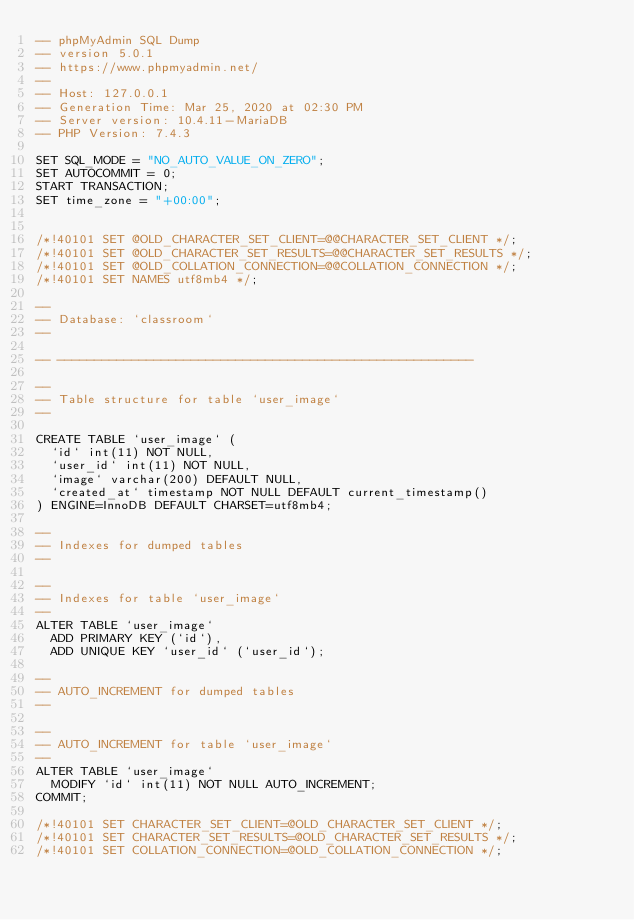Convert code to text. <code><loc_0><loc_0><loc_500><loc_500><_SQL_>-- phpMyAdmin SQL Dump
-- version 5.0.1
-- https://www.phpmyadmin.net/
--
-- Host: 127.0.0.1
-- Generation Time: Mar 25, 2020 at 02:30 PM
-- Server version: 10.4.11-MariaDB
-- PHP Version: 7.4.3

SET SQL_MODE = "NO_AUTO_VALUE_ON_ZERO";
SET AUTOCOMMIT = 0;
START TRANSACTION;
SET time_zone = "+00:00";


/*!40101 SET @OLD_CHARACTER_SET_CLIENT=@@CHARACTER_SET_CLIENT */;
/*!40101 SET @OLD_CHARACTER_SET_RESULTS=@@CHARACTER_SET_RESULTS */;
/*!40101 SET @OLD_COLLATION_CONNECTION=@@COLLATION_CONNECTION */;
/*!40101 SET NAMES utf8mb4 */;

--
-- Database: `classroom`
--

-- --------------------------------------------------------

--
-- Table structure for table `user_image`
--

CREATE TABLE `user_image` (
  `id` int(11) NOT NULL,
  `user_id` int(11) NOT NULL,
  `image` varchar(200) DEFAULT NULL,
  `created_at` timestamp NOT NULL DEFAULT current_timestamp()
) ENGINE=InnoDB DEFAULT CHARSET=utf8mb4;

--
-- Indexes for dumped tables
--

--
-- Indexes for table `user_image`
--
ALTER TABLE `user_image`
  ADD PRIMARY KEY (`id`),
  ADD UNIQUE KEY `user_id` (`user_id`);

--
-- AUTO_INCREMENT for dumped tables
--

--
-- AUTO_INCREMENT for table `user_image`
--
ALTER TABLE `user_image`
  MODIFY `id` int(11) NOT NULL AUTO_INCREMENT;
COMMIT;

/*!40101 SET CHARACTER_SET_CLIENT=@OLD_CHARACTER_SET_CLIENT */;
/*!40101 SET CHARACTER_SET_RESULTS=@OLD_CHARACTER_SET_RESULTS */;
/*!40101 SET COLLATION_CONNECTION=@OLD_COLLATION_CONNECTION */;
</code> 